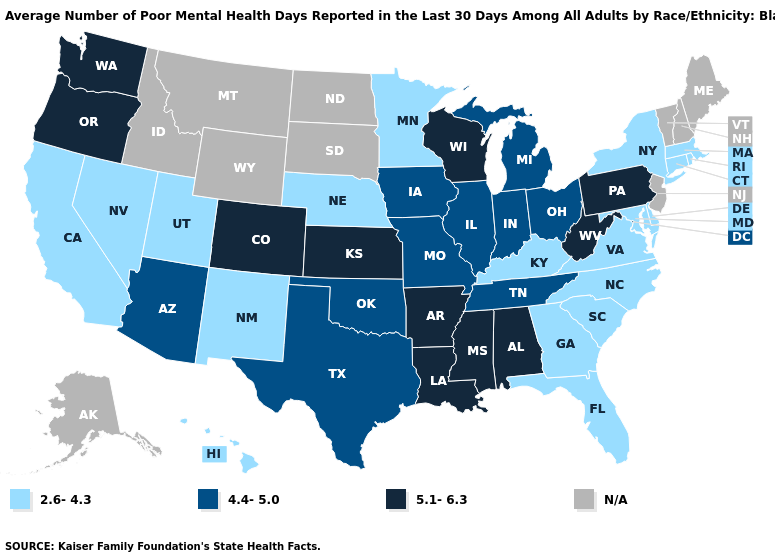Does Ohio have the lowest value in the USA?
Concise answer only. No. Name the states that have a value in the range N/A?
Keep it brief. Alaska, Idaho, Maine, Montana, New Hampshire, New Jersey, North Dakota, South Dakota, Vermont, Wyoming. What is the highest value in states that border Louisiana?
Short answer required. 5.1-6.3. What is the lowest value in the South?
Give a very brief answer. 2.6-4.3. Name the states that have a value in the range 5.1-6.3?
Be succinct. Alabama, Arkansas, Colorado, Kansas, Louisiana, Mississippi, Oregon, Pennsylvania, Washington, West Virginia, Wisconsin. What is the lowest value in states that border Maryland?
Be succinct. 2.6-4.3. Name the states that have a value in the range N/A?
Answer briefly. Alaska, Idaho, Maine, Montana, New Hampshire, New Jersey, North Dakota, South Dakota, Vermont, Wyoming. What is the highest value in the West ?
Concise answer only. 5.1-6.3. Does North Carolina have the highest value in the South?
Keep it brief. No. How many symbols are there in the legend?
Answer briefly. 4. Does Oregon have the highest value in the USA?
Quick response, please. Yes. What is the value of Ohio?
Answer briefly. 4.4-5.0. Name the states that have a value in the range 5.1-6.3?
Concise answer only. Alabama, Arkansas, Colorado, Kansas, Louisiana, Mississippi, Oregon, Pennsylvania, Washington, West Virginia, Wisconsin. Name the states that have a value in the range 4.4-5.0?
Short answer required. Arizona, Illinois, Indiana, Iowa, Michigan, Missouri, Ohio, Oklahoma, Tennessee, Texas. 